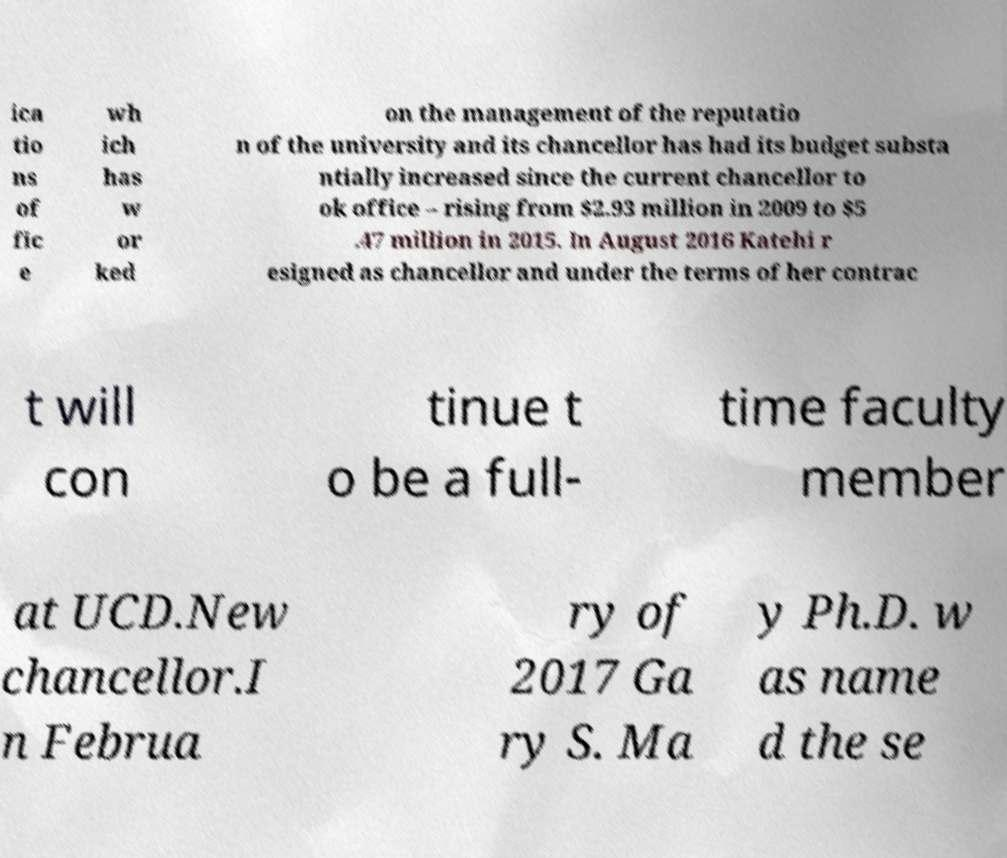Can you accurately transcribe the text from the provided image for me? ica tio ns of fic e wh ich has w or ked on the management of the reputatio n of the university and its chancellor has had its budget substa ntially increased since the current chancellor to ok office – rising from $2.93 million in 2009 to $5 .47 million in 2015. In August 2016 Katehi r esigned as chancellor and under the terms of her contrac t will con tinue t o be a full- time faculty member at UCD.New chancellor.I n Februa ry of 2017 Ga ry S. Ma y Ph.D. w as name d the se 